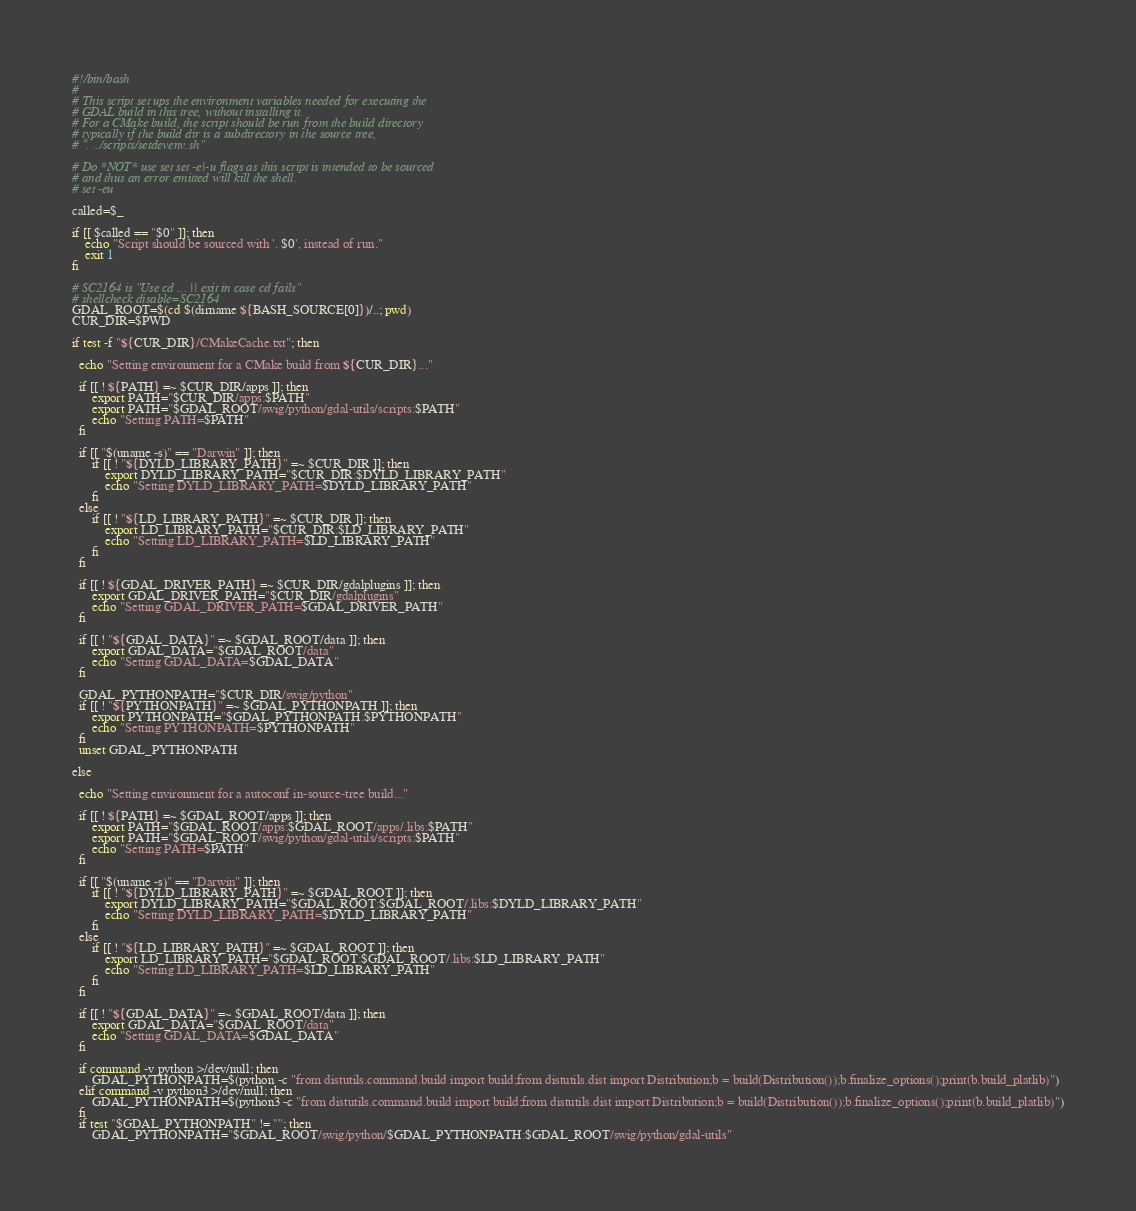<code> <loc_0><loc_0><loc_500><loc_500><_Bash_>#!/bin/bash
#
# This script set ups the environment variables needed for executing the
# GDAL build in this tree, without installing it.
# For a CMake build, the script should be run from the build directory
# typically if the build dir is a subdirectory in the source tree,
# ". ../scripts/setdevenv.sh"

# Do *NOT* use set set -e|-u flags as this script is intended to be sourced
# and thus an error emitted will kill the shell.
# set -eu

called=$_

if [[ $called == "$0" ]]; then
    echo "Script should be sourced with '. $0', instead of run."
    exit 1
fi

# SC2164 is "Use cd ... || exit in case cd fails"
# shellcheck disable=SC2164
GDAL_ROOT=$(cd $(dirname ${BASH_SOURCE[0]})/..; pwd)
CUR_DIR=$PWD

if test -f "${CUR_DIR}/CMakeCache.txt"; then

  echo "Setting environment for a CMake build from ${CUR_DIR}..."

  if [[ ! ${PATH} =~ $CUR_DIR/apps ]]; then
      export PATH="$CUR_DIR/apps:$PATH"
      export PATH="$GDAL_ROOT/swig/python/gdal-utils/scripts:$PATH"
      echo "Setting PATH=$PATH"
  fi

  if [[ "$(uname -s)" == "Darwin" ]]; then
      if [[ ! "${DYLD_LIBRARY_PATH}" =~ $CUR_DIR ]]; then
          export DYLD_LIBRARY_PATH="$CUR_DIR:$DYLD_LIBRARY_PATH"
          echo "Setting DYLD_LIBRARY_PATH=$DYLD_LIBRARY_PATH"
      fi
  else
      if [[ ! "${LD_LIBRARY_PATH}" =~ $CUR_DIR ]]; then
          export LD_LIBRARY_PATH="$CUR_DIR:$LD_LIBRARY_PATH"
          echo "Setting LD_LIBRARY_PATH=$LD_LIBRARY_PATH"
      fi
  fi

  if [[ ! ${GDAL_DRIVER_PATH} =~ $CUR_DIR/gdalplugins ]]; then
      export GDAL_DRIVER_PATH="$CUR_DIR/gdalplugins"
      echo "Setting GDAL_DRIVER_PATH=$GDAL_DRIVER_PATH"
  fi

  if [[ ! "${GDAL_DATA}" =~ $GDAL_ROOT/data ]]; then
      export GDAL_DATA="$GDAL_ROOT/data"
      echo "Setting GDAL_DATA=$GDAL_DATA"
  fi

  GDAL_PYTHONPATH="$CUR_DIR/swig/python"
  if [[ ! "${PYTHONPATH}" =~ $GDAL_PYTHONPATH ]]; then
      export PYTHONPATH="$GDAL_PYTHONPATH:$PYTHONPATH"
      echo "Setting PYTHONPATH=$PYTHONPATH"
  fi
  unset GDAL_PYTHONPATH

else

  echo "Setting environment for a autoconf in-source-tree build..."

  if [[ ! ${PATH} =~ $GDAL_ROOT/apps ]]; then
      export PATH="$GDAL_ROOT/apps:$GDAL_ROOT/apps/.libs:$PATH"
      export PATH="$GDAL_ROOT/swig/python/gdal-utils/scripts:$PATH"
      echo "Setting PATH=$PATH"
  fi

  if [[ "$(uname -s)" == "Darwin" ]]; then
      if [[ ! "${DYLD_LIBRARY_PATH}" =~ $GDAL_ROOT ]]; then
          export DYLD_LIBRARY_PATH="$GDAL_ROOT:$GDAL_ROOT/.libs:$DYLD_LIBRARY_PATH"
          echo "Setting DYLD_LIBRARY_PATH=$DYLD_LIBRARY_PATH"
      fi
  else
      if [[ ! "${LD_LIBRARY_PATH}" =~ $GDAL_ROOT ]]; then
          export LD_LIBRARY_PATH="$GDAL_ROOT:$GDAL_ROOT/.libs:$LD_LIBRARY_PATH"
          echo "Setting LD_LIBRARY_PATH=$LD_LIBRARY_PATH"
      fi
  fi

  if [[ ! "${GDAL_DATA}" =~ $GDAL_ROOT/data ]]; then
      export GDAL_DATA="$GDAL_ROOT/data"
      echo "Setting GDAL_DATA=$GDAL_DATA"
  fi

  if command -v python >/dev/null; then
      GDAL_PYTHONPATH=$(python -c "from distutils.command.build import build;from distutils.dist import Distribution;b = build(Distribution());b.finalize_options();print(b.build_platlib)")
  elif command -v python3 >/dev/null; then
      GDAL_PYTHONPATH=$(python3 -c "from distutils.command.build import build;from distutils.dist import Distribution;b = build(Distribution());b.finalize_options();print(b.build_platlib)")
  fi
  if test "$GDAL_PYTHONPATH" != ""; then
      GDAL_PYTHONPATH="$GDAL_ROOT/swig/python/$GDAL_PYTHONPATH:$GDAL_ROOT/swig/python/gdal-utils"</code> 